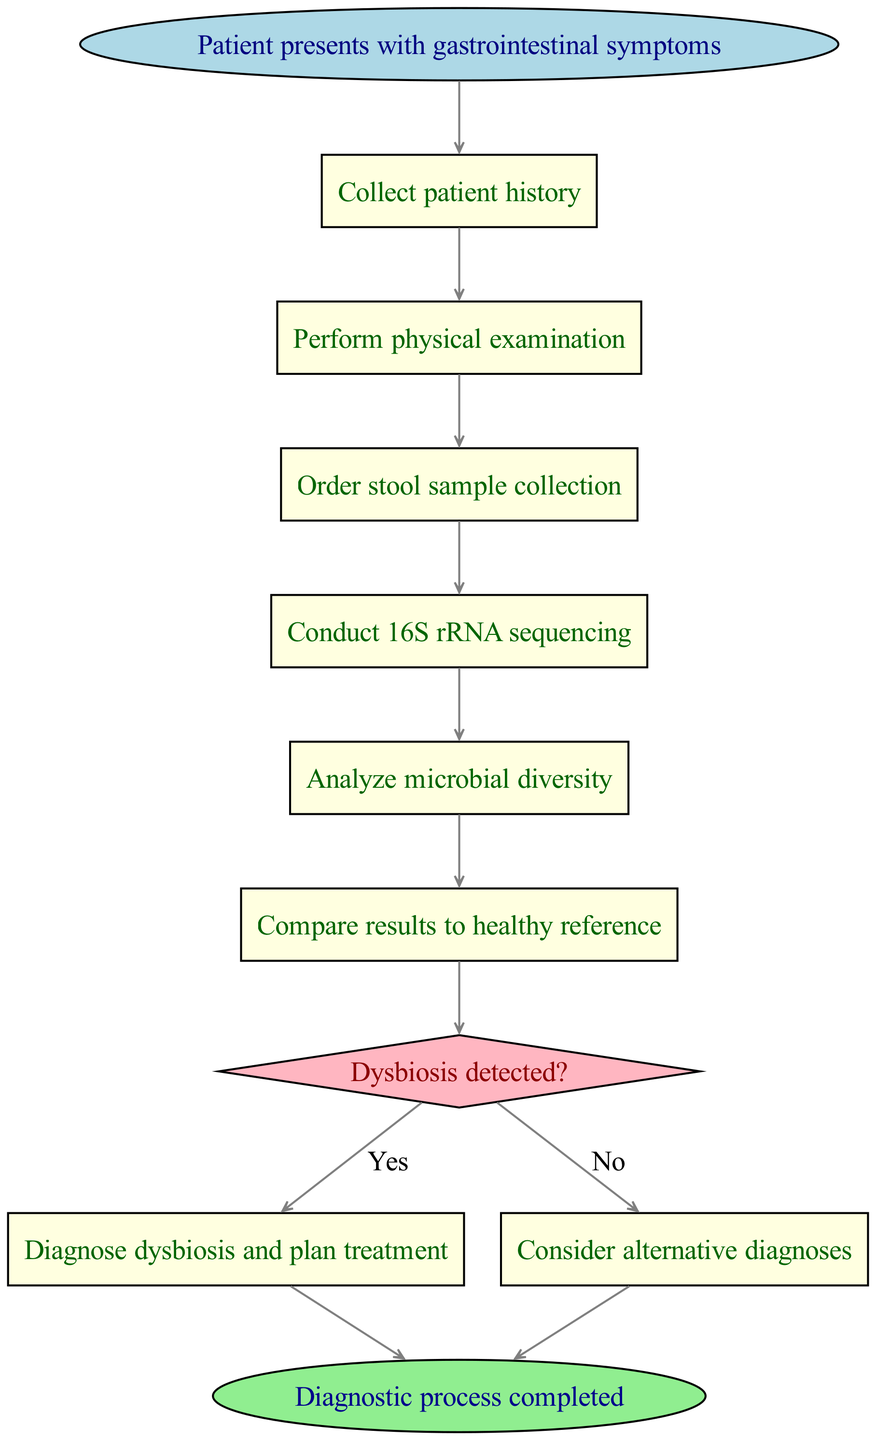What is the first step in the diagnostic process? The first step in the process is represented by the starting node, which states "Patient presents with gastrointestinal symptoms". This indicates that the diagnostic journey begins with the patient's report of symptoms.
Answer: Patient presents with gastrointestinal symptoms How many decision points are in the flowchart? There is one decision point in the flowchart, which occurs at step 7 ("Dysbiosis detected?"). This point branches into two possible next steps based on the outcome.
Answer: 1 What is the outcome if dysbiosis is detected? If dysbiosis is detected, the flowchart directs to step 8, which states "Diagnose dysbiosis and plan treatment". This indicates that the appropriate action is taken upon detection.
Answer: Diagnose dysbiosis and plan treatment What is done after ordering stool sample collection? After ordering stool sample collection, the next step is conducting 16S rRNA sequencing. This follows sequentially from the previous step as part of the diagnostic process.
Answer: Conduct 16S rRNA sequencing What is the process following the analysis of microbial diversity? Following the analysis of microbial diversity, the next step is to compare results to a healthy reference. This is necessary to assess the state of the patient's microbiome.
Answer: Compare results to healthy reference What happens if no dysbiosis is detected? If no dysbiosis is detected, the flowchart leads to step 9, where it suggests "Consider alternative diagnoses". This means that other potential health issues should be evaluated.
Answer: Consider alternative diagnoses What type of examination is performed after collecting patient history? A physical examination is performed after collecting patient history, as stated in the flow of the diagnostic process.
Answer: Perform physical examination Which node ends the diagnostic process? The diagnostic process concludes with the end node, which simply states "Diagnostic process completed". This denotes the completion of all steps outlined in the flowchart.
Answer: Diagnostic process completed 